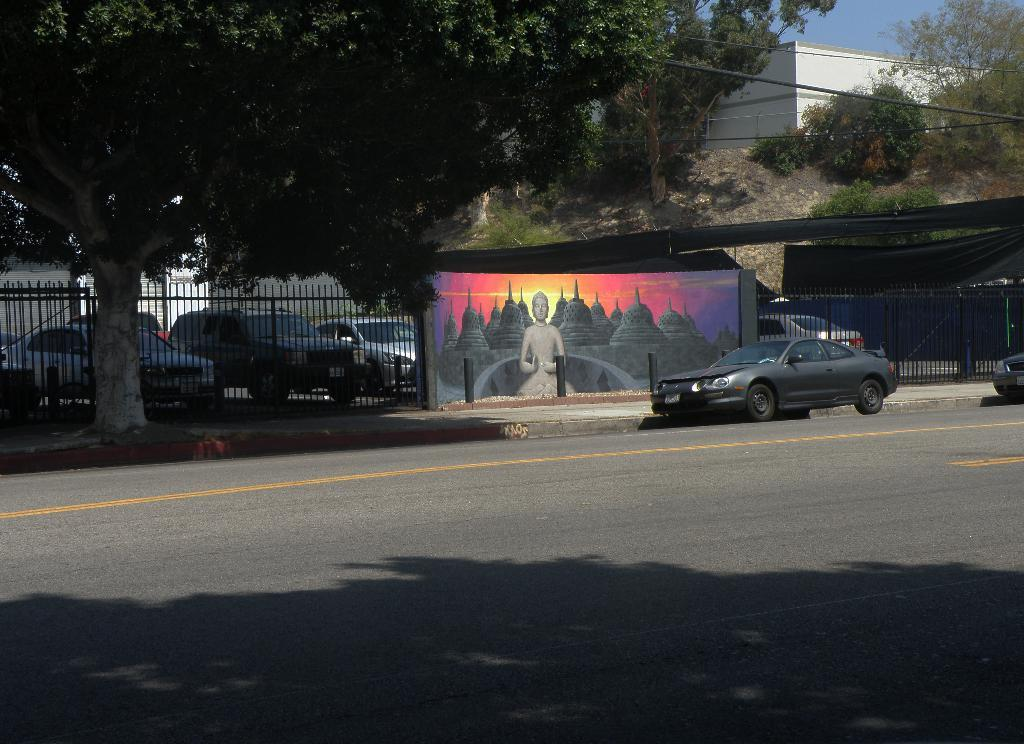What types of objects can be seen in the image? There are vehicles, a wall with art, a road, trees, plants, the ground, houses, and poles visible in the image. Can you describe the wall with art in the image? The wall with art has a design or image on it. What is the primary surface visible in the image? The ground is the primary surface visible in the image. How many types of structures can be seen in the image? There are houses and a wall visible in the image, making a total of two types of structures. How many fish can be seen swimming in the image? There are no fish visible in the image. What fact can be learned about the cows in the image? There are no cows present in the image, so no fact about cows can be learned. 